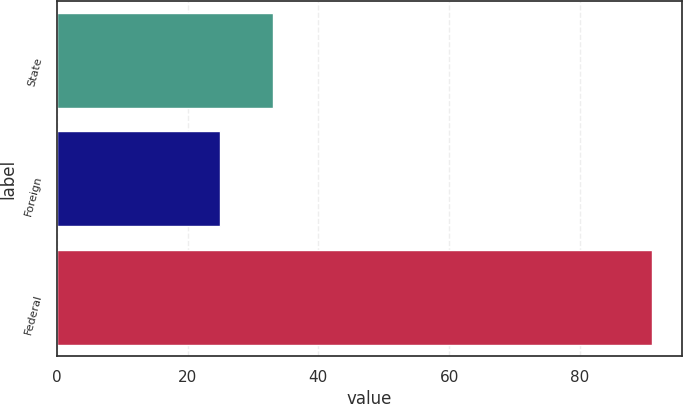Convert chart. <chart><loc_0><loc_0><loc_500><loc_500><bar_chart><fcel>State<fcel>Foreign<fcel>Federal<nl><fcel>33<fcel>25<fcel>91<nl></chart> 